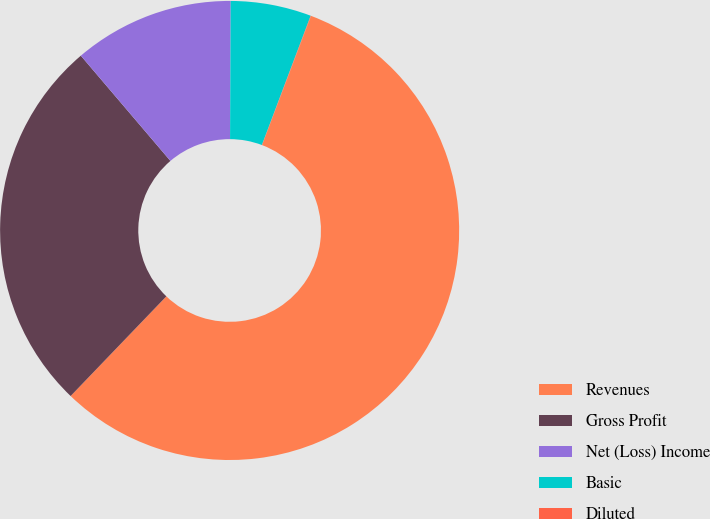Convert chart to OTSL. <chart><loc_0><loc_0><loc_500><loc_500><pie_chart><fcel>Revenues<fcel>Gross Profit<fcel>Net (Loss) Income<fcel>Basic<fcel>Diluted<nl><fcel>56.41%<fcel>26.6%<fcel>11.3%<fcel>5.67%<fcel>0.03%<nl></chart> 